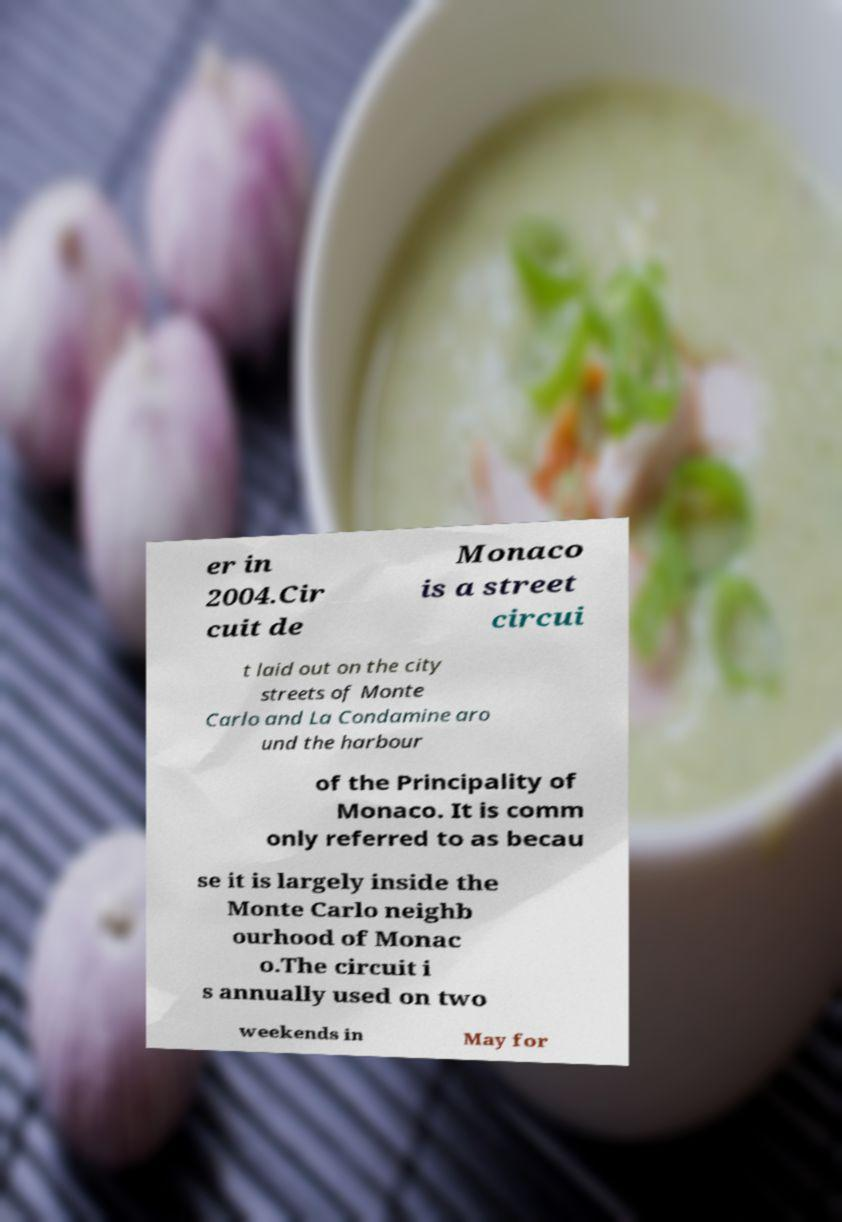Can you read and provide the text displayed in the image?This photo seems to have some interesting text. Can you extract and type it out for me? er in 2004.Cir cuit de Monaco is a street circui t laid out on the city streets of Monte Carlo and La Condamine aro und the harbour of the Principality of Monaco. It is comm only referred to as becau se it is largely inside the Monte Carlo neighb ourhood of Monac o.The circuit i s annually used on two weekends in May for 